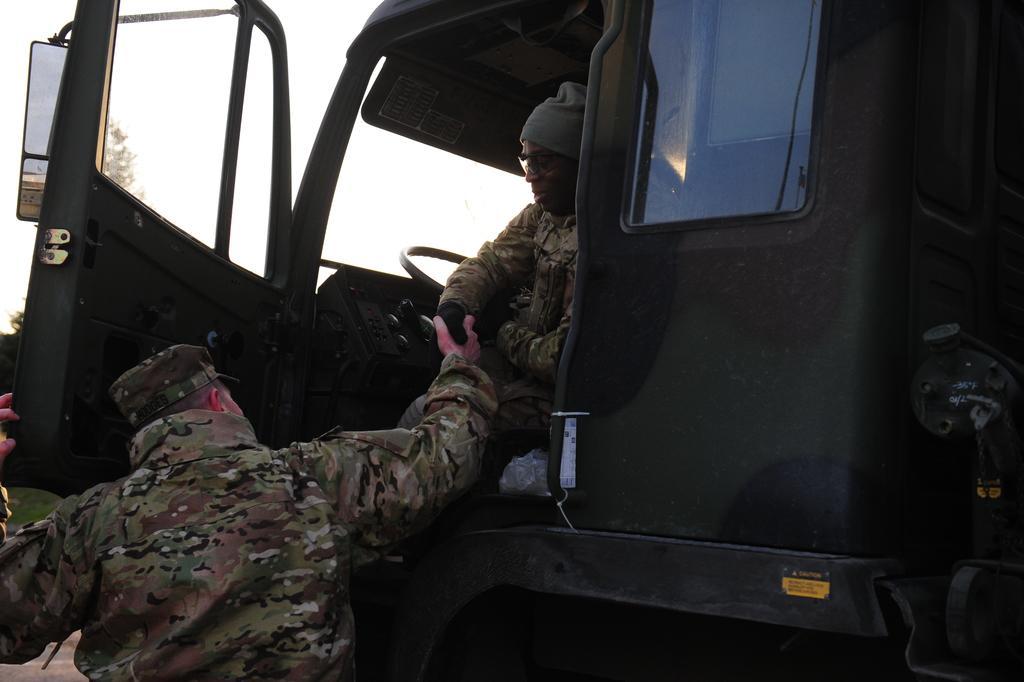Can you describe this image briefly? In this image I can see a vehicle and here I can see two men. I can see both of them are wearing uniforms, caps and here I can see one of them is wearing specs. 